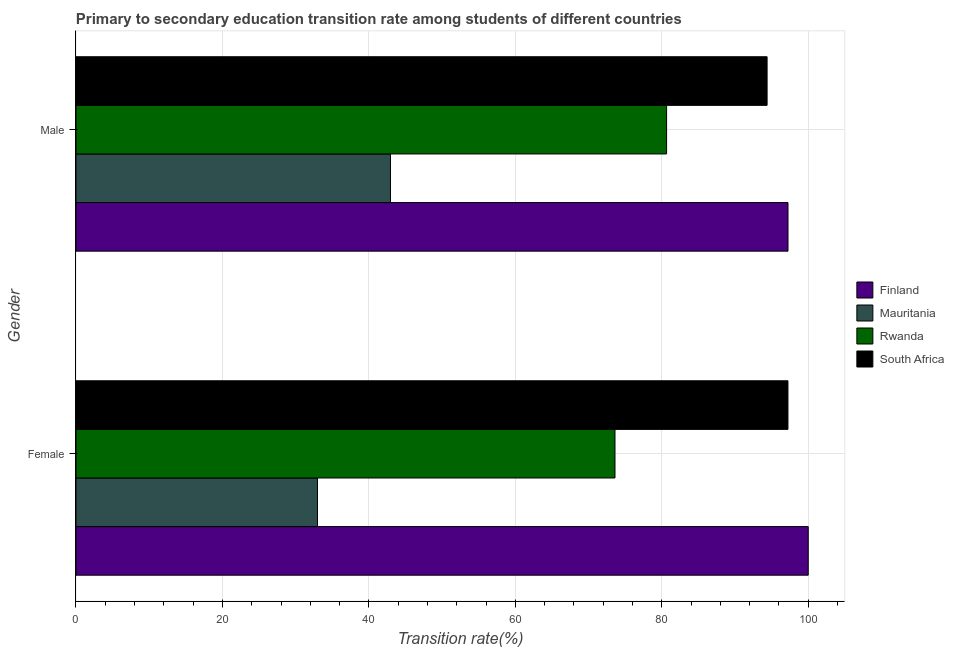How many groups of bars are there?
Provide a succinct answer. 2. Are the number of bars per tick equal to the number of legend labels?
Your answer should be very brief. Yes. What is the label of the 2nd group of bars from the top?
Offer a very short reply. Female. What is the transition rate among male students in Rwanda?
Your answer should be very brief. 80.66. Across all countries, what is the maximum transition rate among male students?
Make the answer very short. 97.23. Across all countries, what is the minimum transition rate among female students?
Ensure brevity in your answer.  32.98. In which country was the transition rate among female students minimum?
Make the answer very short. Mauritania. What is the total transition rate among male students in the graph?
Make the answer very short. 315.22. What is the difference between the transition rate among female students in South Africa and that in Finland?
Ensure brevity in your answer.  -2.77. What is the difference between the transition rate among female students in Finland and the transition rate among male students in Rwanda?
Ensure brevity in your answer.  19.34. What is the average transition rate among male students per country?
Give a very brief answer. 78.8. What is the difference between the transition rate among female students and transition rate among male students in Mauritania?
Give a very brief answer. -9.97. What is the ratio of the transition rate among male students in Mauritania to that in Rwanda?
Provide a succinct answer. 0.53. What does the 1st bar from the top in Male represents?
Your answer should be very brief. South Africa. What does the 1st bar from the bottom in Female represents?
Ensure brevity in your answer.  Finland. How many bars are there?
Give a very brief answer. 8. Are all the bars in the graph horizontal?
Keep it short and to the point. Yes. Does the graph contain any zero values?
Offer a very short reply. No. Does the graph contain grids?
Provide a succinct answer. Yes. Where does the legend appear in the graph?
Make the answer very short. Center right. How many legend labels are there?
Keep it short and to the point. 4. What is the title of the graph?
Your answer should be very brief. Primary to secondary education transition rate among students of different countries. Does "Jamaica" appear as one of the legend labels in the graph?
Give a very brief answer. No. What is the label or title of the X-axis?
Keep it short and to the point. Transition rate(%). What is the label or title of the Y-axis?
Your response must be concise. Gender. What is the Transition rate(%) in Finland in Female?
Offer a terse response. 100. What is the Transition rate(%) of Mauritania in Female?
Your answer should be very brief. 32.98. What is the Transition rate(%) in Rwanda in Female?
Offer a terse response. 73.61. What is the Transition rate(%) in South Africa in Female?
Ensure brevity in your answer.  97.23. What is the Transition rate(%) in Finland in Male?
Your response must be concise. 97.23. What is the Transition rate(%) of Mauritania in Male?
Offer a very short reply. 42.95. What is the Transition rate(%) of Rwanda in Male?
Give a very brief answer. 80.66. What is the Transition rate(%) in South Africa in Male?
Your response must be concise. 94.38. Across all Gender, what is the maximum Transition rate(%) in Mauritania?
Your answer should be compact. 42.95. Across all Gender, what is the maximum Transition rate(%) in Rwanda?
Provide a short and direct response. 80.66. Across all Gender, what is the maximum Transition rate(%) in South Africa?
Provide a short and direct response. 97.23. Across all Gender, what is the minimum Transition rate(%) of Finland?
Ensure brevity in your answer.  97.23. Across all Gender, what is the minimum Transition rate(%) of Mauritania?
Give a very brief answer. 32.98. Across all Gender, what is the minimum Transition rate(%) in Rwanda?
Give a very brief answer. 73.61. Across all Gender, what is the minimum Transition rate(%) of South Africa?
Offer a terse response. 94.38. What is the total Transition rate(%) of Finland in the graph?
Keep it short and to the point. 197.24. What is the total Transition rate(%) of Mauritania in the graph?
Provide a short and direct response. 75.93. What is the total Transition rate(%) in Rwanda in the graph?
Your response must be concise. 154.26. What is the total Transition rate(%) in South Africa in the graph?
Provide a succinct answer. 191.61. What is the difference between the Transition rate(%) in Finland in Female and that in Male?
Provide a short and direct response. 2.77. What is the difference between the Transition rate(%) in Mauritania in Female and that in Male?
Give a very brief answer. -9.97. What is the difference between the Transition rate(%) of Rwanda in Female and that in Male?
Your answer should be very brief. -7.05. What is the difference between the Transition rate(%) of South Africa in Female and that in Male?
Offer a terse response. 2.85. What is the difference between the Transition rate(%) in Finland in Female and the Transition rate(%) in Mauritania in Male?
Keep it short and to the point. 57.05. What is the difference between the Transition rate(%) in Finland in Female and the Transition rate(%) in Rwanda in Male?
Give a very brief answer. 19.34. What is the difference between the Transition rate(%) of Finland in Female and the Transition rate(%) of South Africa in Male?
Provide a succinct answer. 5.62. What is the difference between the Transition rate(%) in Mauritania in Female and the Transition rate(%) in Rwanda in Male?
Your answer should be compact. -47.68. What is the difference between the Transition rate(%) in Mauritania in Female and the Transition rate(%) in South Africa in Male?
Provide a short and direct response. -61.4. What is the difference between the Transition rate(%) of Rwanda in Female and the Transition rate(%) of South Africa in Male?
Provide a succinct answer. -20.77. What is the average Transition rate(%) in Finland per Gender?
Provide a succinct answer. 98.62. What is the average Transition rate(%) of Mauritania per Gender?
Your answer should be compact. 37.96. What is the average Transition rate(%) in Rwanda per Gender?
Provide a succinct answer. 77.13. What is the average Transition rate(%) in South Africa per Gender?
Offer a very short reply. 95.81. What is the difference between the Transition rate(%) in Finland and Transition rate(%) in Mauritania in Female?
Offer a terse response. 67.02. What is the difference between the Transition rate(%) in Finland and Transition rate(%) in Rwanda in Female?
Make the answer very short. 26.39. What is the difference between the Transition rate(%) in Finland and Transition rate(%) in South Africa in Female?
Provide a succinct answer. 2.77. What is the difference between the Transition rate(%) in Mauritania and Transition rate(%) in Rwanda in Female?
Provide a short and direct response. -40.63. What is the difference between the Transition rate(%) in Mauritania and Transition rate(%) in South Africa in Female?
Your answer should be compact. -64.25. What is the difference between the Transition rate(%) in Rwanda and Transition rate(%) in South Africa in Female?
Ensure brevity in your answer.  -23.62. What is the difference between the Transition rate(%) in Finland and Transition rate(%) in Mauritania in Male?
Give a very brief answer. 54.29. What is the difference between the Transition rate(%) in Finland and Transition rate(%) in Rwanda in Male?
Your answer should be compact. 16.58. What is the difference between the Transition rate(%) in Finland and Transition rate(%) in South Africa in Male?
Your answer should be compact. 2.85. What is the difference between the Transition rate(%) of Mauritania and Transition rate(%) of Rwanda in Male?
Your answer should be very brief. -37.71. What is the difference between the Transition rate(%) of Mauritania and Transition rate(%) of South Africa in Male?
Your answer should be compact. -51.43. What is the difference between the Transition rate(%) of Rwanda and Transition rate(%) of South Africa in Male?
Keep it short and to the point. -13.72. What is the ratio of the Transition rate(%) in Finland in Female to that in Male?
Your answer should be compact. 1.03. What is the ratio of the Transition rate(%) in Mauritania in Female to that in Male?
Your answer should be compact. 0.77. What is the ratio of the Transition rate(%) in Rwanda in Female to that in Male?
Offer a terse response. 0.91. What is the ratio of the Transition rate(%) in South Africa in Female to that in Male?
Your answer should be very brief. 1.03. What is the difference between the highest and the second highest Transition rate(%) of Finland?
Provide a short and direct response. 2.77. What is the difference between the highest and the second highest Transition rate(%) of Mauritania?
Offer a very short reply. 9.97. What is the difference between the highest and the second highest Transition rate(%) of Rwanda?
Make the answer very short. 7.05. What is the difference between the highest and the second highest Transition rate(%) in South Africa?
Your response must be concise. 2.85. What is the difference between the highest and the lowest Transition rate(%) of Finland?
Your response must be concise. 2.77. What is the difference between the highest and the lowest Transition rate(%) in Mauritania?
Provide a succinct answer. 9.97. What is the difference between the highest and the lowest Transition rate(%) in Rwanda?
Provide a short and direct response. 7.05. What is the difference between the highest and the lowest Transition rate(%) in South Africa?
Provide a succinct answer. 2.85. 